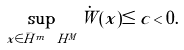<formula> <loc_0><loc_0><loc_500><loc_500>\sup _ { x \in \bar { H } ^ { m } \ H ^ { M } } \dot { W } ( x ) \leq c < 0 .</formula> 